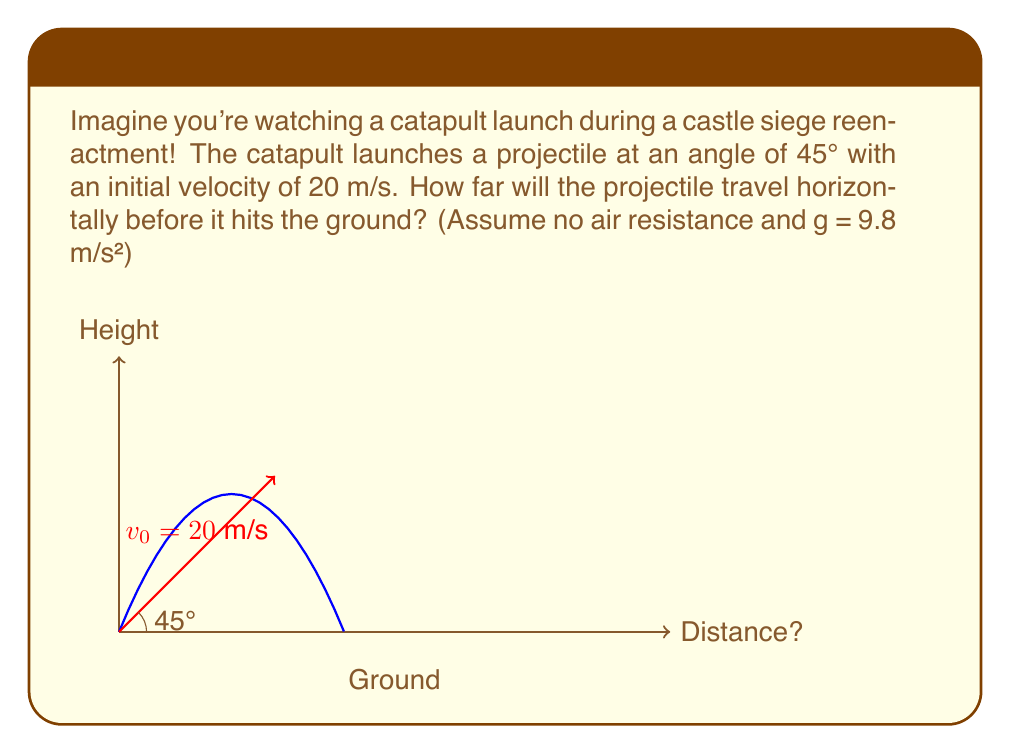Provide a solution to this math problem. Let's solve this step-by-step:

1) For projectile motion, we can use the equation:
   $$x = v_0 \cos(\theta) \cdot t$$
   where $x$ is the horizontal distance, $v_0$ is the initial velocity, $\theta$ is the launch angle, and $t$ is the time of flight.

2) To find $t$, we can use the equation for vertical motion:
   $$y = v_0 \sin(\theta) \cdot t - \frac{1}{2}gt^2$$
   
3) At the point of impact, $y = 0$. So:
   $$0 = v_0 \sin(\theta) \cdot t - \frac{1}{2}gt^2$$

4) Solving this quadratic equation:
   $$t = \frac{2v_0 \sin(\theta)}{g}$$

5) Substituting the given values ($v_0 = 20$ m/s, $\theta = 45°$, $g = 9.8$ m/s²):
   $$t = \frac{2 \cdot 20 \cdot \sin(45°)}{9.8} = \frac{2 \cdot 20 \cdot 0.707}{9.8} \approx 2.89 \text{ s}$$

6) Now we can use this time in the horizontal distance equation:
   $$x = v_0 \cos(\theta) \cdot t$$
   $$x = 20 \cdot \cos(45°) \cdot 2.89$$
   $$x = 20 \cdot 0.707 \cdot 2.89 \approx 40.8 \text{ m}$$

Therefore, the projectile will travel approximately 40.8 meters horizontally before hitting the ground.
Answer: 40.8 m 